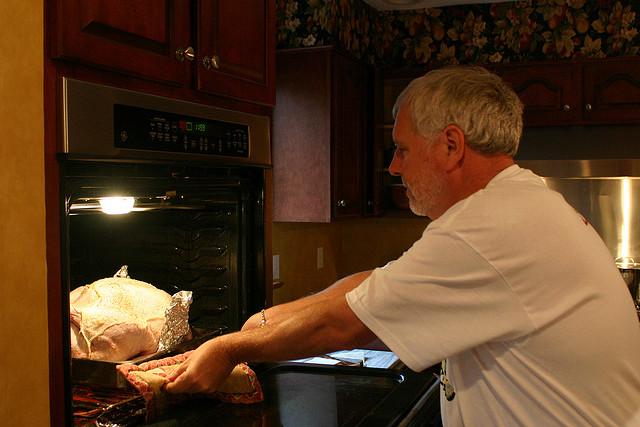What is being cooked?
Be succinct. Turkey. What does the top of the oven say?
Be succinct. 11:59. Does the man seem excited?
Short answer required. No. What is the man cooking?
Give a very brief answer. Turkey. What is on the blond man's head?
Short answer required. Hair. How many armbands is the man wearing?
Write a very short answer. 1. Is he wearing sunglasses?
Short answer required. No. What is the man reaching into?
Short answer required. Oven. What kind of fuel powers the stove?
Keep it brief. Electricity. Is this a safe way to cook?
Write a very short answer. Yes. What is the man doing?
Concise answer only. Cooking. How many cakes are the men cooking?
Quick response, please. 0. Is the man old or young?
Give a very brief answer. Old. Which wrist does the man have a bracelet on?
Answer briefly. Right. 